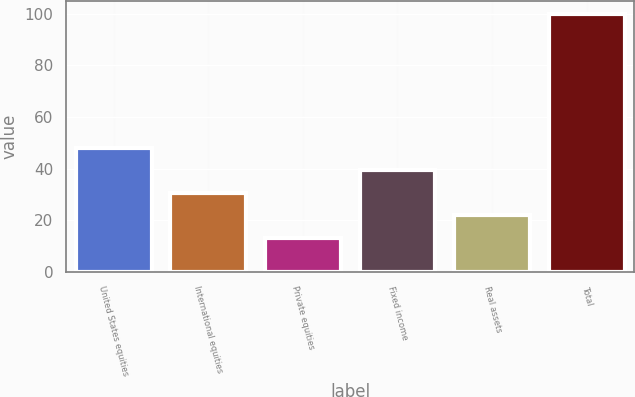Convert chart. <chart><loc_0><loc_0><loc_500><loc_500><bar_chart><fcel>United States equities<fcel>International equities<fcel>Private equities<fcel>Fixed income<fcel>Real assets<fcel>Total<nl><fcel>47.98<fcel>30.64<fcel>13.3<fcel>39.31<fcel>21.97<fcel>100<nl></chart> 